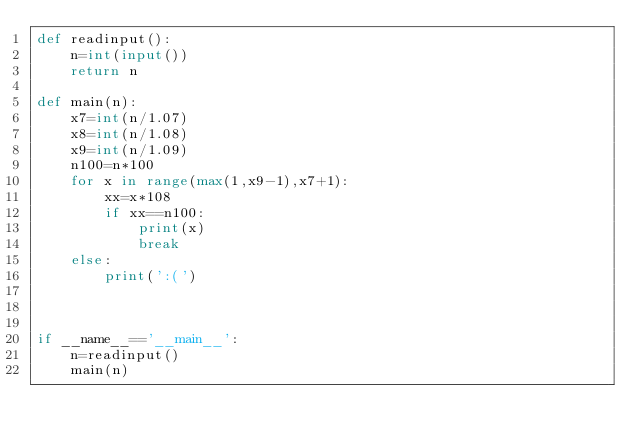Convert code to text. <code><loc_0><loc_0><loc_500><loc_500><_Python_>def readinput():
    n=int(input())
    return n

def main(n):
    x7=int(n/1.07)
    x8=int(n/1.08)
    x9=int(n/1.09)
    n100=n*100
    for x in range(max(1,x9-1),x7+1):
        xx=x*108
        if xx==n100:
            print(x)
            break
    else:
        print(':(')

        

if __name__=='__main__':
    n=readinput()
    main(n)
</code> 